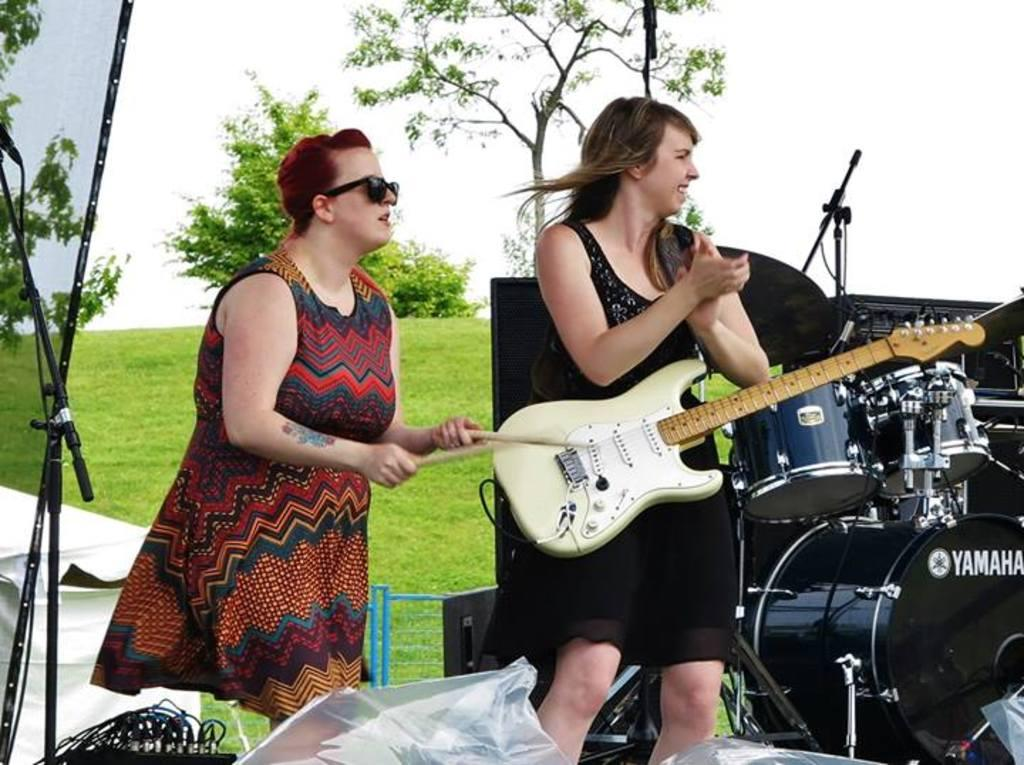How many people are present in the image? There are two persons standing in the image. What are the persons doing in the image? They are likely playing musical instruments, as they are visible in the image. What type of natural environment is present in the image? There is grass and trees in the image, suggesting a natural setting. What can be seen in the background of the image? The sky is visible in the background of the image. How many babies are crawling on the grass in the image? There are no babies present in the image; it features two persons playing musical instruments. What type of society is depicted in the image? The image does not depict a society; it shows two persons playing musical instruments in a natural setting. 